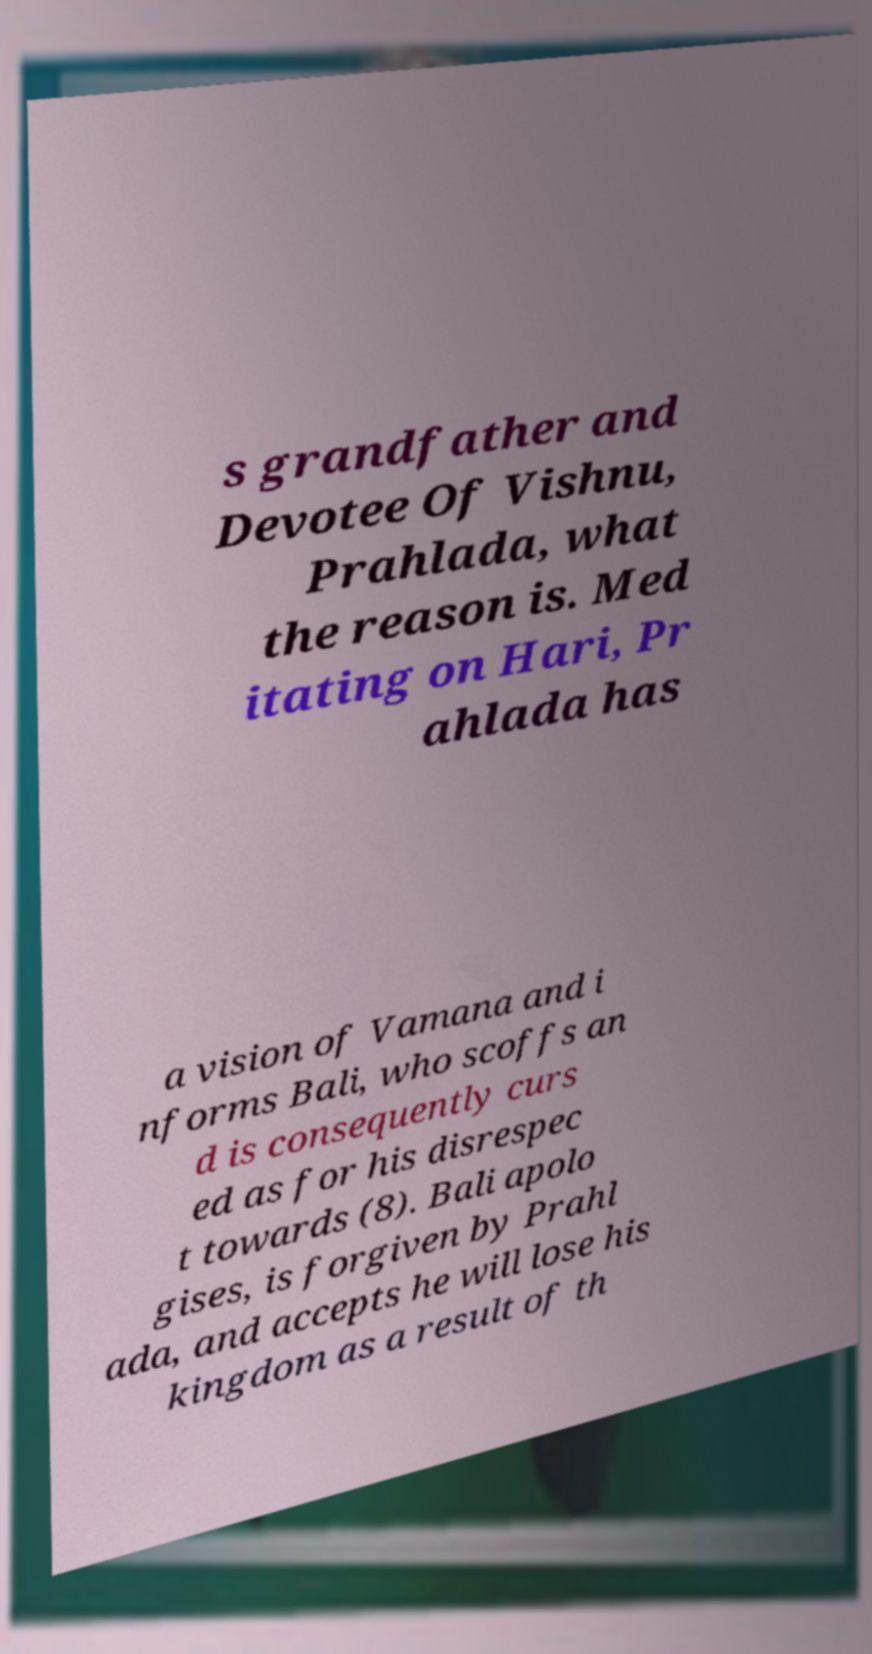Can you accurately transcribe the text from the provided image for me? s grandfather and Devotee Of Vishnu, Prahlada, what the reason is. Med itating on Hari, Pr ahlada has a vision of Vamana and i nforms Bali, who scoffs an d is consequently curs ed as for his disrespec t towards (8). Bali apolo gises, is forgiven by Prahl ada, and accepts he will lose his kingdom as a result of th 